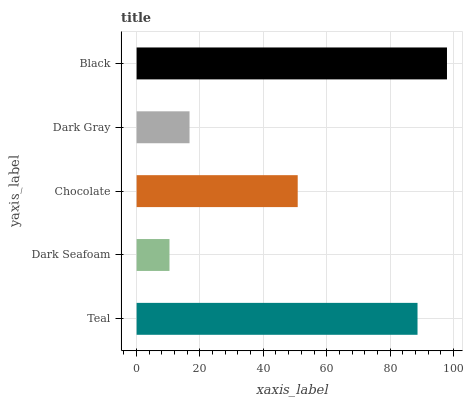Is Dark Seafoam the minimum?
Answer yes or no. Yes. Is Black the maximum?
Answer yes or no. Yes. Is Chocolate the minimum?
Answer yes or no. No. Is Chocolate the maximum?
Answer yes or no. No. Is Chocolate greater than Dark Seafoam?
Answer yes or no. Yes. Is Dark Seafoam less than Chocolate?
Answer yes or no. Yes. Is Dark Seafoam greater than Chocolate?
Answer yes or no. No. Is Chocolate less than Dark Seafoam?
Answer yes or no. No. Is Chocolate the high median?
Answer yes or no. Yes. Is Chocolate the low median?
Answer yes or no. Yes. Is Dark Seafoam the high median?
Answer yes or no. No. Is Dark Gray the low median?
Answer yes or no. No. 